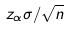<formula> <loc_0><loc_0><loc_500><loc_500>z _ { \alpha } \sigma / \sqrt { n }</formula> 